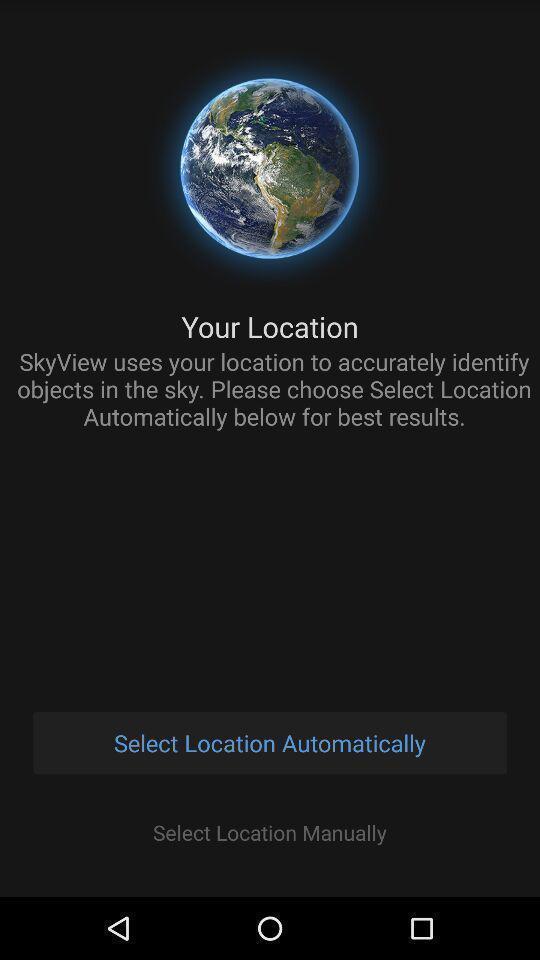Summarize the main components in this picture. Select location page of a planet discovery app. 